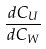Convert formula to latex. <formula><loc_0><loc_0><loc_500><loc_500>\frac { d C _ { U } } { d C _ { W } }</formula> 